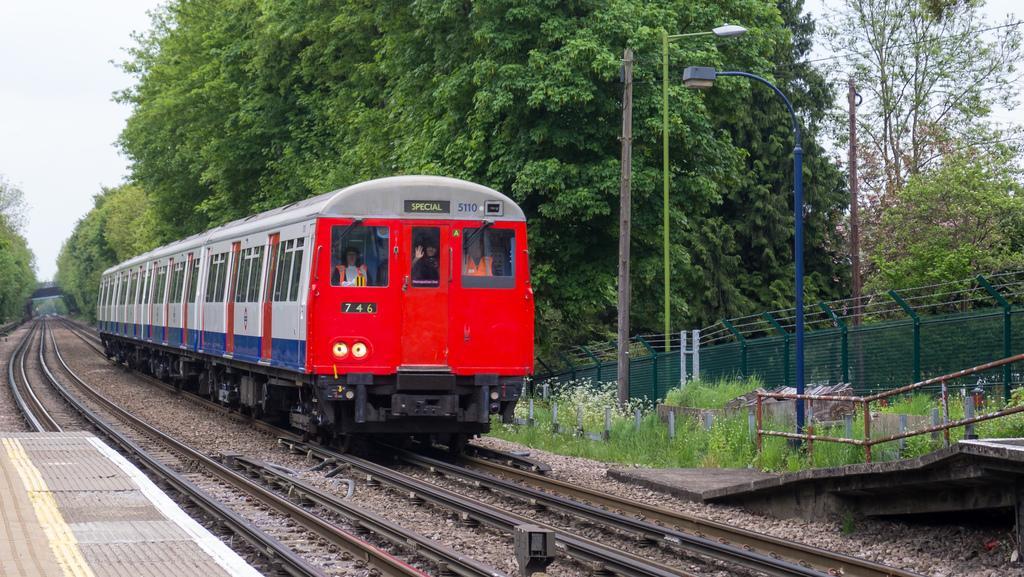Please provide a concise description of this image. This picture shows a train on the railway track and we see few people in the train and we see couple of pole lights and poles and we see a metal fence and trees and a cloudy sky and we see a platform on the side. The train is red grey and blue in color. 